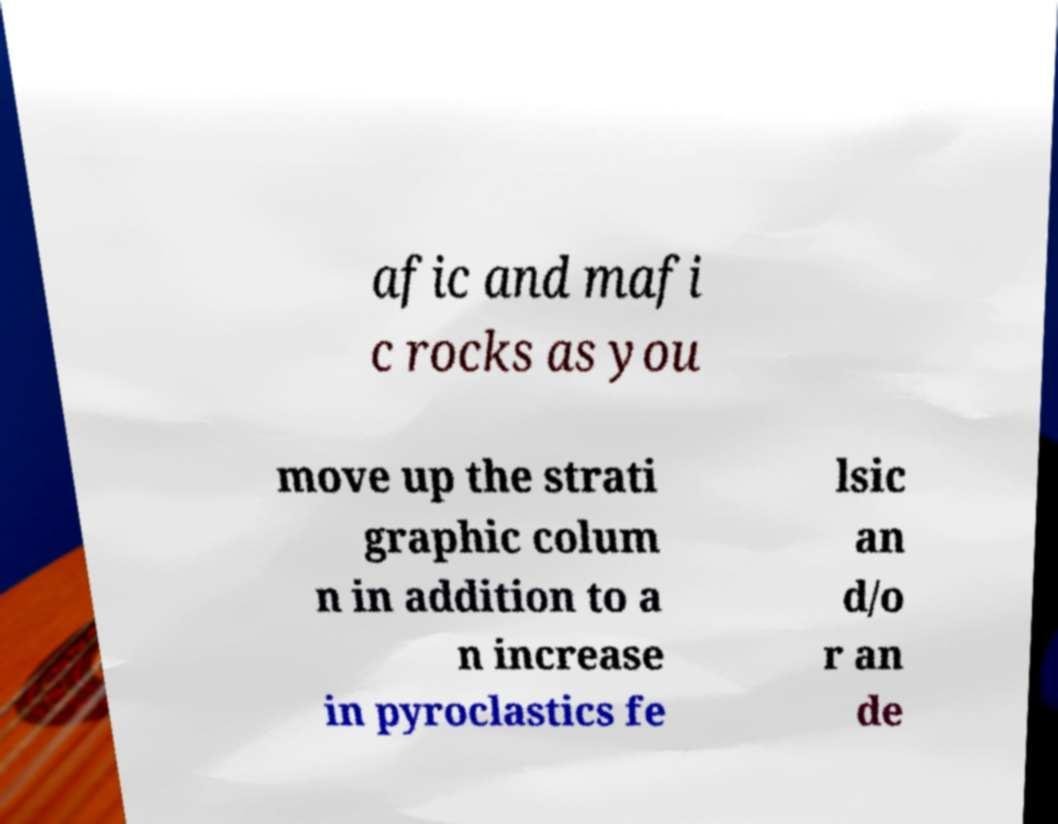For documentation purposes, I need the text within this image transcribed. Could you provide that? afic and mafi c rocks as you move up the strati graphic colum n in addition to a n increase in pyroclastics fe lsic an d/o r an de 